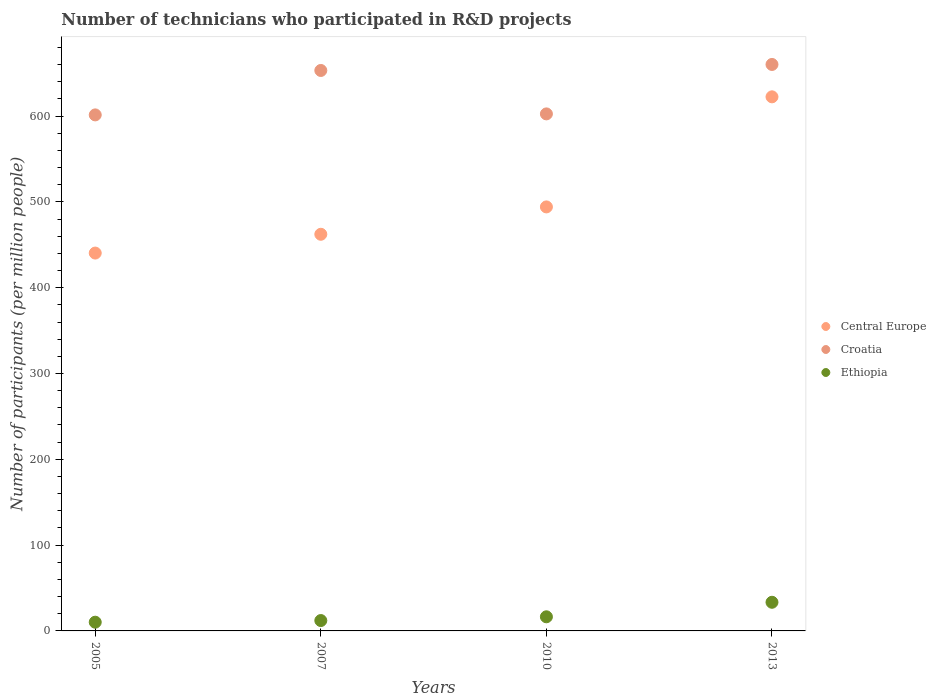Is the number of dotlines equal to the number of legend labels?
Offer a very short reply. Yes. What is the number of technicians who participated in R&D projects in Ethiopia in 2005?
Your answer should be compact. 10.17. Across all years, what is the maximum number of technicians who participated in R&D projects in Ethiopia?
Ensure brevity in your answer.  33.38. Across all years, what is the minimum number of technicians who participated in R&D projects in Central Europe?
Offer a terse response. 440.38. In which year was the number of technicians who participated in R&D projects in Central Europe minimum?
Ensure brevity in your answer.  2005. What is the total number of technicians who participated in R&D projects in Croatia in the graph?
Your answer should be very brief. 2517.37. What is the difference between the number of technicians who participated in R&D projects in Central Europe in 2005 and that in 2013?
Provide a succinct answer. -182.08. What is the difference between the number of technicians who participated in R&D projects in Croatia in 2013 and the number of technicians who participated in R&D projects in Ethiopia in 2007?
Provide a succinct answer. 648.1. What is the average number of technicians who participated in R&D projects in Central Europe per year?
Make the answer very short. 504.82. In the year 2010, what is the difference between the number of technicians who participated in R&D projects in Central Europe and number of technicians who participated in R&D projects in Ethiopia?
Your answer should be compact. 477.71. What is the ratio of the number of technicians who participated in R&D projects in Ethiopia in 2010 to that in 2013?
Offer a terse response. 0.49. What is the difference between the highest and the second highest number of technicians who participated in R&D projects in Ethiopia?
Provide a short and direct response. 16.93. What is the difference between the highest and the lowest number of technicians who participated in R&D projects in Central Europe?
Provide a short and direct response. 182.08. Is the sum of the number of technicians who participated in R&D projects in Ethiopia in 2005 and 2013 greater than the maximum number of technicians who participated in R&D projects in Central Europe across all years?
Offer a very short reply. No. Is it the case that in every year, the sum of the number of technicians who participated in R&D projects in Croatia and number of technicians who participated in R&D projects in Ethiopia  is greater than the number of technicians who participated in R&D projects in Central Europe?
Give a very brief answer. Yes. Does the number of technicians who participated in R&D projects in Central Europe monotonically increase over the years?
Your answer should be very brief. Yes. Is the number of technicians who participated in R&D projects in Central Europe strictly less than the number of technicians who participated in R&D projects in Ethiopia over the years?
Provide a succinct answer. No. What is the difference between two consecutive major ticks on the Y-axis?
Offer a terse response. 100. Are the values on the major ticks of Y-axis written in scientific E-notation?
Your response must be concise. No. Where does the legend appear in the graph?
Your answer should be very brief. Center right. How many legend labels are there?
Provide a succinct answer. 3. How are the legend labels stacked?
Ensure brevity in your answer.  Vertical. What is the title of the graph?
Make the answer very short. Number of technicians who participated in R&D projects. What is the label or title of the Y-axis?
Your answer should be very brief. Number of participants (per million people). What is the Number of participants (per million people) of Central Europe in 2005?
Keep it short and to the point. 440.38. What is the Number of participants (per million people) in Croatia in 2005?
Provide a short and direct response. 601.41. What is the Number of participants (per million people) in Ethiopia in 2005?
Keep it short and to the point. 10.17. What is the Number of participants (per million people) in Central Europe in 2007?
Your response must be concise. 462.27. What is the Number of participants (per million people) of Croatia in 2007?
Provide a short and direct response. 653.18. What is the Number of participants (per million people) of Ethiopia in 2007?
Provide a succinct answer. 12.09. What is the Number of participants (per million people) in Central Europe in 2010?
Your response must be concise. 494.17. What is the Number of participants (per million people) of Croatia in 2010?
Your response must be concise. 602.58. What is the Number of participants (per million people) in Ethiopia in 2010?
Your response must be concise. 16.46. What is the Number of participants (per million people) of Central Europe in 2013?
Provide a succinct answer. 622.46. What is the Number of participants (per million people) in Croatia in 2013?
Give a very brief answer. 660.19. What is the Number of participants (per million people) in Ethiopia in 2013?
Your answer should be very brief. 33.38. Across all years, what is the maximum Number of participants (per million people) of Central Europe?
Offer a very short reply. 622.46. Across all years, what is the maximum Number of participants (per million people) in Croatia?
Offer a very short reply. 660.19. Across all years, what is the maximum Number of participants (per million people) of Ethiopia?
Offer a very short reply. 33.38. Across all years, what is the minimum Number of participants (per million people) in Central Europe?
Make the answer very short. 440.38. Across all years, what is the minimum Number of participants (per million people) in Croatia?
Your answer should be compact. 601.41. Across all years, what is the minimum Number of participants (per million people) in Ethiopia?
Offer a terse response. 10.17. What is the total Number of participants (per million people) of Central Europe in the graph?
Your answer should be compact. 2019.28. What is the total Number of participants (per million people) of Croatia in the graph?
Keep it short and to the point. 2517.37. What is the total Number of participants (per million people) of Ethiopia in the graph?
Give a very brief answer. 72.1. What is the difference between the Number of participants (per million people) of Central Europe in 2005 and that in 2007?
Provide a short and direct response. -21.9. What is the difference between the Number of participants (per million people) in Croatia in 2005 and that in 2007?
Make the answer very short. -51.78. What is the difference between the Number of participants (per million people) of Ethiopia in 2005 and that in 2007?
Provide a succinct answer. -1.92. What is the difference between the Number of participants (per million people) in Central Europe in 2005 and that in 2010?
Give a very brief answer. -53.79. What is the difference between the Number of participants (per million people) of Croatia in 2005 and that in 2010?
Your answer should be very brief. -1.17. What is the difference between the Number of participants (per million people) of Ethiopia in 2005 and that in 2010?
Keep it short and to the point. -6.29. What is the difference between the Number of participants (per million people) in Central Europe in 2005 and that in 2013?
Give a very brief answer. -182.08. What is the difference between the Number of participants (per million people) in Croatia in 2005 and that in 2013?
Your answer should be very brief. -58.78. What is the difference between the Number of participants (per million people) of Ethiopia in 2005 and that in 2013?
Offer a very short reply. -23.21. What is the difference between the Number of participants (per million people) of Central Europe in 2007 and that in 2010?
Keep it short and to the point. -31.9. What is the difference between the Number of participants (per million people) in Croatia in 2007 and that in 2010?
Your answer should be compact. 50.6. What is the difference between the Number of participants (per million people) in Ethiopia in 2007 and that in 2010?
Provide a short and direct response. -4.37. What is the difference between the Number of participants (per million people) in Central Europe in 2007 and that in 2013?
Offer a terse response. -160.19. What is the difference between the Number of participants (per million people) in Croatia in 2007 and that in 2013?
Make the answer very short. -7.01. What is the difference between the Number of participants (per million people) of Ethiopia in 2007 and that in 2013?
Provide a short and direct response. -21.29. What is the difference between the Number of participants (per million people) of Central Europe in 2010 and that in 2013?
Provide a succinct answer. -128.29. What is the difference between the Number of participants (per million people) in Croatia in 2010 and that in 2013?
Offer a terse response. -57.61. What is the difference between the Number of participants (per million people) of Ethiopia in 2010 and that in 2013?
Your answer should be very brief. -16.93. What is the difference between the Number of participants (per million people) in Central Europe in 2005 and the Number of participants (per million people) in Croatia in 2007?
Give a very brief answer. -212.81. What is the difference between the Number of participants (per million people) of Central Europe in 2005 and the Number of participants (per million people) of Ethiopia in 2007?
Make the answer very short. 428.29. What is the difference between the Number of participants (per million people) of Croatia in 2005 and the Number of participants (per million people) of Ethiopia in 2007?
Provide a short and direct response. 589.32. What is the difference between the Number of participants (per million people) of Central Europe in 2005 and the Number of participants (per million people) of Croatia in 2010?
Your response must be concise. -162.2. What is the difference between the Number of participants (per million people) in Central Europe in 2005 and the Number of participants (per million people) in Ethiopia in 2010?
Provide a succinct answer. 423.92. What is the difference between the Number of participants (per million people) in Croatia in 2005 and the Number of participants (per million people) in Ethiopia in 2010?
Your response must be concise. 584.95. What is the difference between the Number of participants (per million people) in Central Europe in 2005 and the Number of participants (per million people) in Croatia in 2013?
Make the answer very short. -219.81. What is the difference between the Number of participants (per million people) in Central Europe in 2005 and the Number of participants (per million people) in Ethiopia in 2013?
Your answer should be compact. 407. What is the difference between the Number of participants (per million people) of Croatia in 2005 and the Number of participants (per million people) of Ethiopia in 2013?
Provide a short and direct response. 568.03. What is the difference between the Number of participants (per million people) of Central Europe in 2007 and the Number of participants (per million people) of Croatia in 2010?
Provide a succinct answer. -140.31. What is the difference between the Number of participants (per million people) of Central Europe in 2007 and the Number of participants (per million people) of Ethiopia in 2010?
Keep it short and to the point. 445.82. What is the difference between the Number of participants (per million people) of Croatia in 2007 and the Number of participants (per million people) of Ethiopia in 2010?
Make the answer very short. 636.73. What is the difference between the Number of participants (per million people) of Central Europe in 2007 and the Number of participants (per million people) of Croatia in 2013?
Ensure brevity in your answer.  -197.92. What is the difference between the Number of participants (per million people) in Central Europe in 2007 and the Number of participants (per million people) in Ethiopia in 2013?
Provide a short and direct response. 428.89. What is the difference between the Number of participants (per million people) in Croatia in 2007 and the Number of participants (per million people) in Ethiopia in 2013?
Your response must be concise. 619.8. What is the difference between the Number of participants (per million people) of Central Europe in 2010 and the Number of participants (per million people) of Croatia in 2013?
Your answer should be compact. -166.02. What is the difference between the Number of participants (per million people) of Central Europe in 2010 and the Number of participants (per million people) of Ethiopia in 2013?
Make the answer very short. 460.79. What is the difference between the Number of participants (per million people) of Croatia in 2010 and the Number of participants (per million people) of Ethiopia in 2013?
Give a very brief answer. 569.2. What is the average Number of participants (per million people) in Central Europe per year?
Make the answer very short. 504.82. What is the average Number of participants (per million people) in Croatia per year?
Your answer should be very brief. 629.34. What is the average Number of participants (per million people) in Ethiopia per year?
Your response must be concise. 18.02. In the year 2005, what is the difference between the Number of participants (per million people) of Central Europe and Number of participants (per million people) of Croatia?
Make the answer very short. -161.03. In the year 2005, what is the difference between the Number of participants (per million people) of Central Europe and Number of participants (per million people) of Ethiopia?
Give a very brief answer. 430.21. In the year 2005, what is the difference between the Number of participants (per million people) in Croatia and Number of participants (per million people) in Ethiopia?
Your answer should be very brief. 591.24. In the year 2007, what is the difference between the Number of participants (per million people) of Central Europe and Number of participants (per million people) of Croatia?
Give a very brief answer. -190.91. In the year 2007, what is the difference between the Number of participants (per million people) in Central Europe and Number of participants (per million people) in Ethiopia?
Keep it short and to the point. 450.18. In the year 2007, what is the difference between the Number of participants (per million people) of Croatia and Number of participants (per million people) of Ethiopia?
Offer a terse response. 641.09. In the year 2010, what is the difference between the Number of participants (per million people) in Central Europe and Number of participants (per million people) in Croatia?
Give a very brief answer. -108.41. In the year 2010, what is the difference between the Number of participants (per million people) in Central Europe and Number of participants (per million people) in Ethiopia?
Ensure brevity in your answer.  477.71. In the year 2010, what is the difference between the Number of participants (per million people) in Croatia and Number of participants (per million people) in Ethiopia?
Make the answer very short. 586.12. In the year 2013, what is the difference between the Number of participants (per million people) in Central Europe and Number of participants (per million people) in Croatia?
Your answer should be compact. -37.73. In the year 2013, what is the difference between the Number of participants (per million people) in Central Europe and Number of participants (per million people) in Ethiopia?
Keep it short and to the point. 589.08. In the year 2013, what is the difference between the Number of participants (per million people) of Croatia and Number of participants (per million people) of Ethiopia?
Provide a short and direct response. 626.81. What is the ratio of the Number of participants (per million people) of Central Europe in 2005 to that in 2007?
Provide a succinct answer. 0.95. What is the ratio of the Number of participants (per million people) in Croatia in 2005 to that in 2007?
Offer a very short reply. 0.92. What is the ratio of the Number of participants (per million people) of Ethiopia in 2005 to that in 2007?
Make the answer very short. 0.84. What is the ratio of the Number of participants (per million people) of Central Europe in 2005 to that in 2010?
Offer a very short reply. 0.89. What is the ratio of the Number of participants (per million people) in Croatia in 2005 to that in 2010?
Make the answer very short. 1. What is the ratio of the Number of participants (per million people) of Ethiopia in 2005 to that in 2010?
Your answer should be very brief. 0.62. What is the ratio of the Number of participants (per million people) in Central Europe in 2005 to that in 2013?
Give a very brief answer. 0.71. What is the ratio of the Number of participants (per million people) in Croatia in 2005 to that in 2013?
Ensure brevity in your answer.  0.91. What is the ratio of the Number of participants (per million people) of Ethiopia in 2005 to that in 2013?
Offer a terse response. 0.3. What is the ratio of the Number of participants (per million people) in Central Europe in 2007 to that in 2010?
Provide a short and direct response. 0.94. What is the ratio of the Number of participants (per million people) in Croatia in 2007 to that in 2010?
Ensure brevity in your answer.  1.08. What is the ratio of the Number of participants (per million people) of Ethiopia in 2007 to that in 2010?
Your answer should be compact. 0.73. What is the ratio of the Number of participants (per million people) in Central Europe in 2007 to that in 2013?
Make the answer very short. 0.74. What is the ratio of the Number of participants (per million people) of Ethiopia in 2007 to that in 2013?
Offer a very short reply. 0.36. What is the ratio of the Number of participants (per million people) in Central Europe in 2010 to that in 2013?
Your response must be concise. 0.79. What is the ratio of the Number of participants (per million people) of Croatia in 2010 to that in 2013?
Give a very brief answer. 0.91. What is the ratio of the Number of participants (per million people) of Ethiopia in 2010 to that in 2013?
Ensure brevity in your answer.  0.49. What is the difference between the highest and the second highest Number of participants (per million people) in Central Europe?
Keep it short and to the point. 128.29. What is the difference between the highest and the second highest Number of participants (per million people) of Croatia?
Offer a terse response. 7.01. What is the difference between the highest and the second highest Number of participants (per million people) of Ethiopia?
Provide a succinct answer. 16.93. What is the difference between the highest and the lowest Number of participants (per million people) in Central Europe?
Keep it short and to the point. 182.08. What is the difference between the highest and the lowest Number of participants (per million people) of Croatia?
Ensure brevity in your answer.  58.78. What is the difference between the highest and the lowest Number of participants (per million people) of Ethiopia?
Make the answer very short. 23.21. 